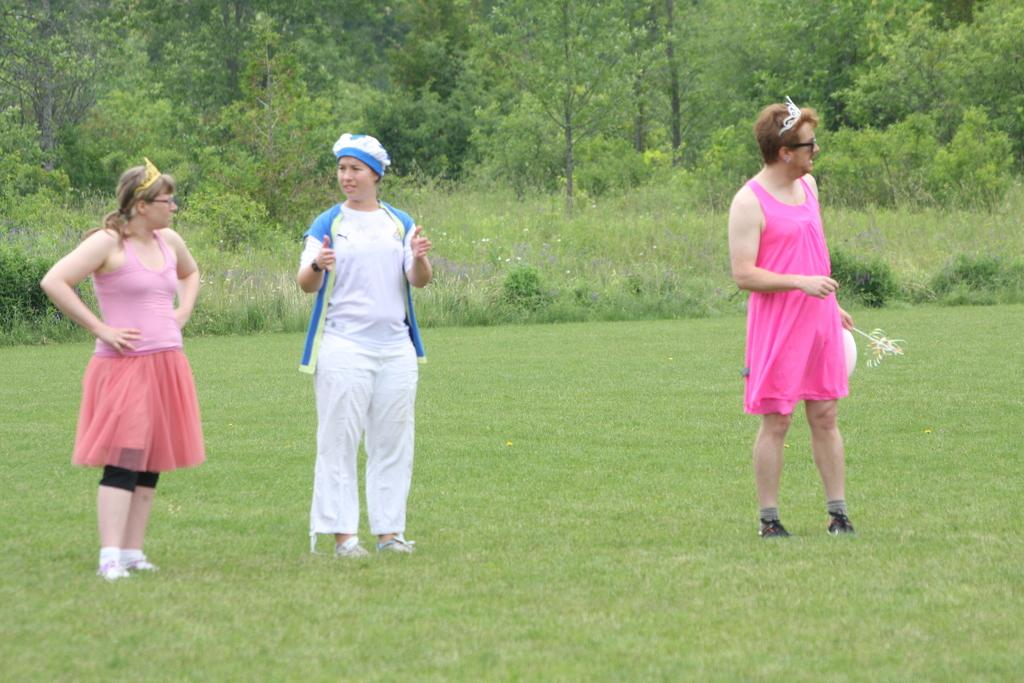How many people are in the image? There are three persons in the image. What is one of the persons doing with their hand? One of the persons is holding an object in their hand. What type of vegetation can be seen in the image? There is green grass visible in the image, as well as plants and trees in the background. What type of hook is being used to hang the party decorations in the image? There is no hook or party decorations present in the image. 